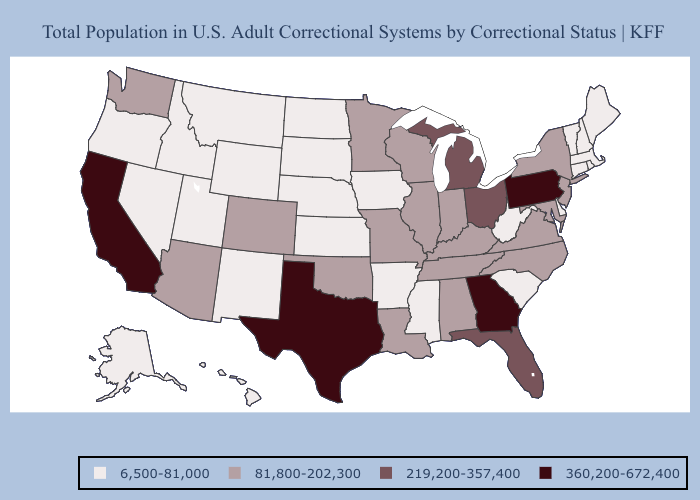Name the states that have a value in the range 219,200-357,400?
Write a very short answer. Florida, Michigan, Ohio. What is the lowest value in the Northeast?
Short answer required. 6,500-81,000. Name the states that have a value in the range 6,500-81,000?
Short answer required. Alaska, Arkansas, Connecticut, Delaware, Hawaii, Idaho, Iowa, Kansas, Maine, Massachusetts, Mississippi, Montana, Nebraska, Nevada, New Hampshire, New Mexico, North Dakota, Oregon, Rhode Island, South Carolina, South Dakota, Utah, Vermont, West Virginia, Wyoming. What is the highest value in the South ?
Answer briefly. 360,200-672,400. Does Texas have a lower value than South Carolina?
Write a very short answer. No. Does Tennessee have a higher value than West Virginia?
Keep it brief. Yes. Name the states that have a value in the range 360,200-672,400?
Quick response, please. California, Georgia, Pennsylvania, Texas. What is the value of Maine?
Quick response, please. 6,500-81,000. Name the states that have a value in the range 219,200-357,400?
Be succinct. Florida, Michigan, Ohio. Among the states that border Alabama , does Mississippi have the highest value?
Give a very brief answer. No. What is the highest value in the Northeast ?
Short answer required. 360,200-672,400. Name the states that have a value in the range 219,200-357,400?
Write a very short answer. Florida, Michigan, Ohio. Among the states that border Indiana , which have the highest value?
Concise answer only. Michigan, Ohio. Name the states that have a value in the range 360,200-672,400?
Quick response, please. California, Georgia, Pennsylvania, Texas. 